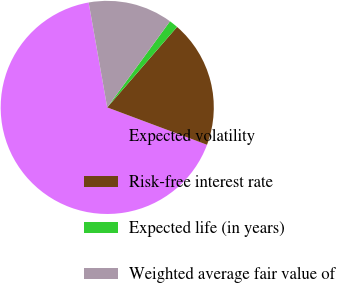Convert chart. <chart><loc_0><loc_0><loc_500><loc_500><pie_chart><fcel>Expected volatility<fcel>Risk-free interest rate<fcel>Expected life (in years)<fcel>Weighted average fair value of<nl><fcel>66.5%<fcel>19.33%<fcel>1.35%<fcel>12.81%<nl></chart> 